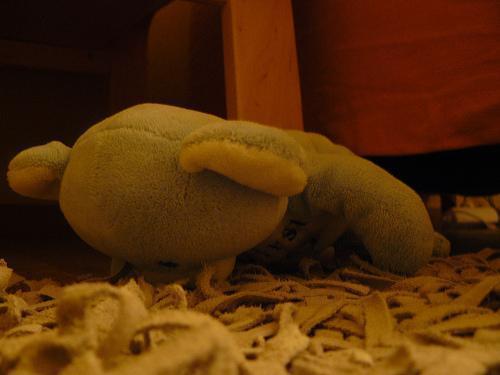How many red bouncy balls are on the ground in front of the teddy bear?
Give a very brief answer. 0. 